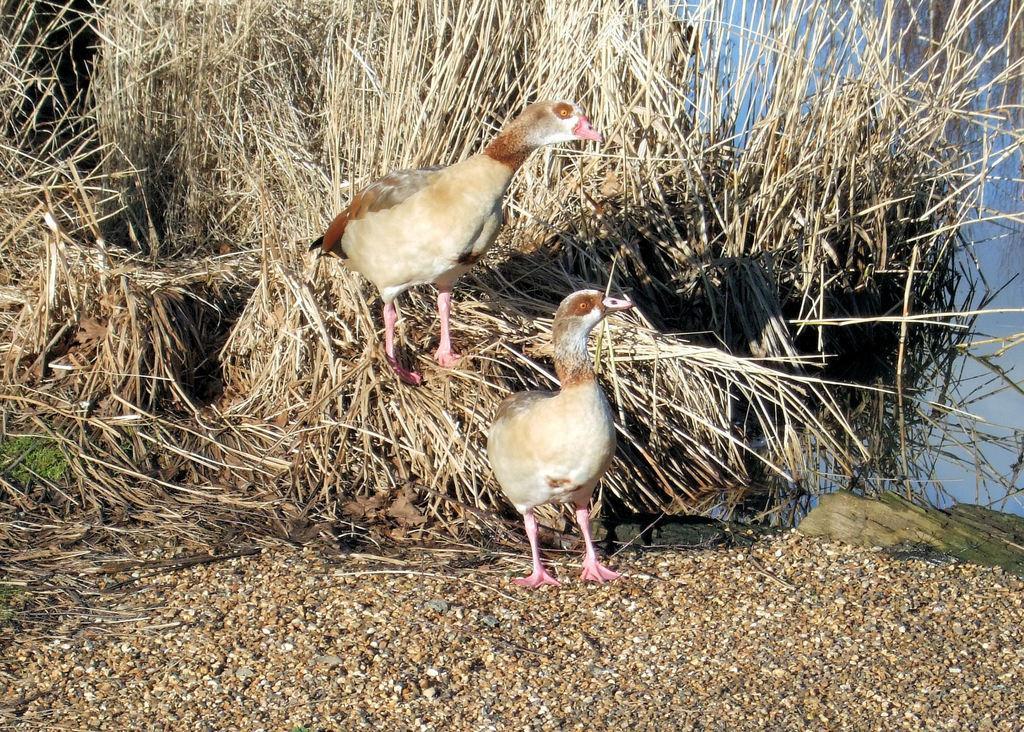How would you summarize this image in a sentence or two? In this picture there are two ducks who are standing near to the grass. On the right there is a water. On the left we can see the green grass. In the bottom left we can see the stone. 